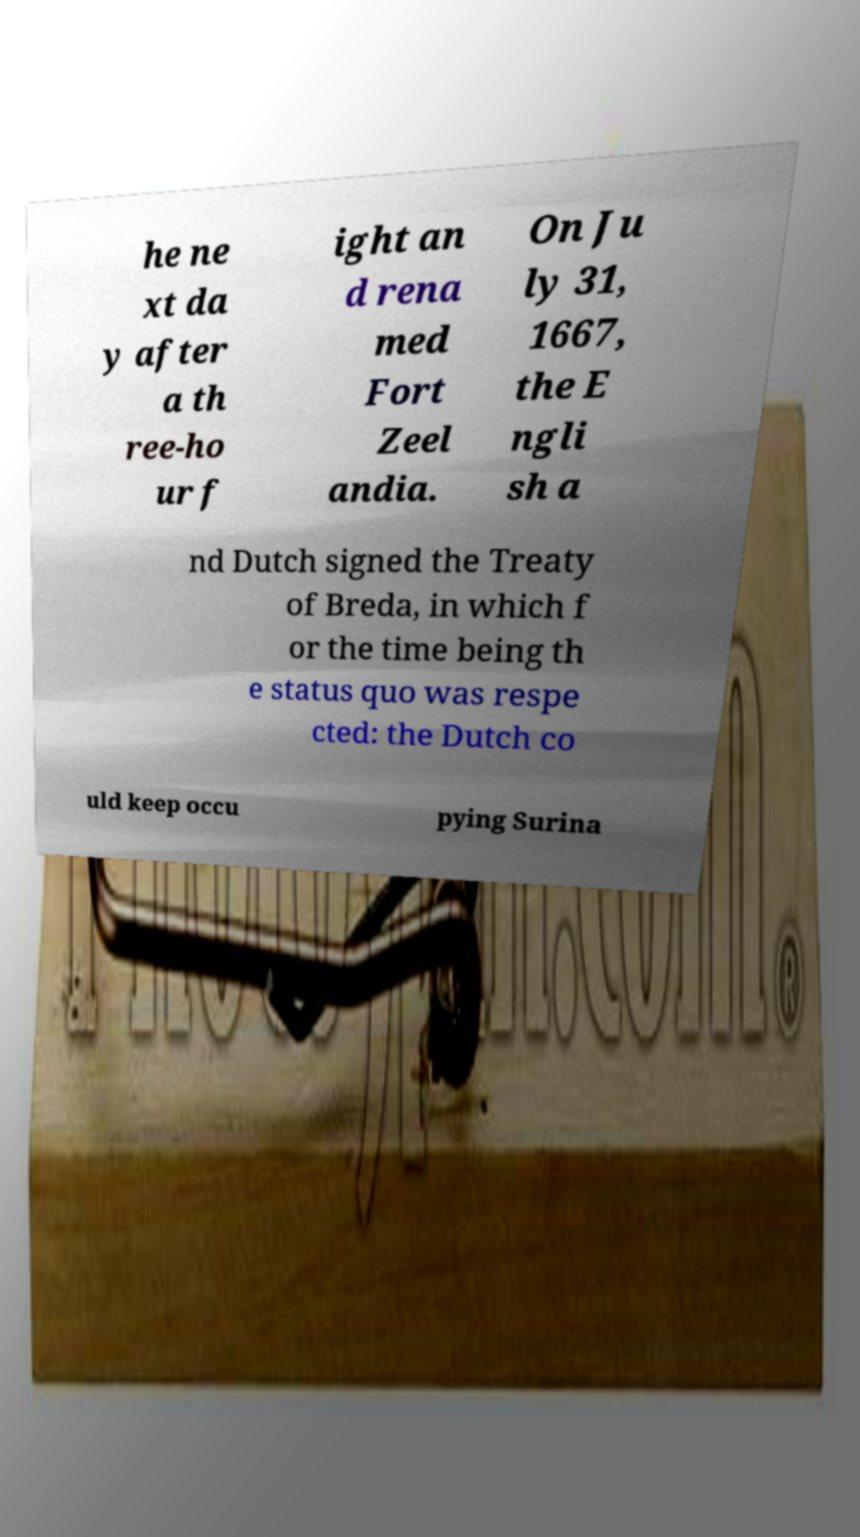What messages or text are displayed in this image? I need them in a readable, typed format. he ne xt da y after a th ree-ho ur f ight an d rena med Fort Zeel andia. On Ju ly 31, 1667, the E ngli sh a nd Dutch signed the Treaty of Breda, in which f or the time being th e status quo was respe cted: the Dutch co uld keep occu pying Surina 